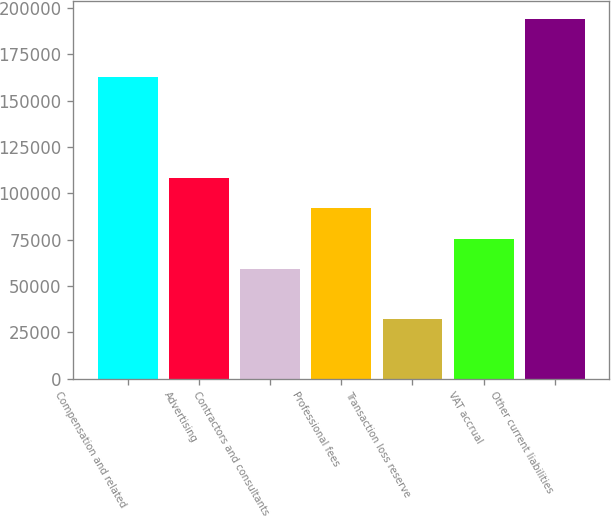<chart> <loc_0><loc_0><loc_500><loc_500><bar_chart><fcel>Compensation and related<fcel>Advertising<fcel>Contractors and consultants<fcel>Professional fees<fcel>Transaction loss reserve<fcel>VAT accrual<fcel>Other current liabilities<nl><fcel>162889<fcel>107979<fcel>59371<fcel>91776.6<fcel>32140<fcel>75573.8<fcel>194168<nl></chart> 